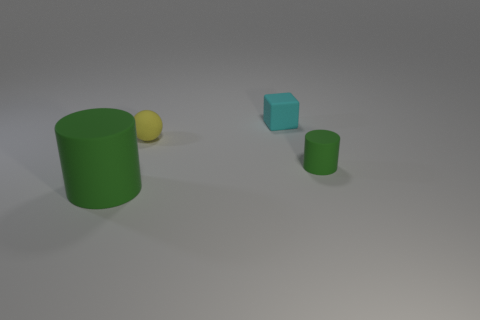Can you tell what the light source in the image is like? It seems that the light source is coming from the upper left, casting soft shadows to the right of the objects, indicating a diffused light that softly illuminates the scene without harsh contrasts. 